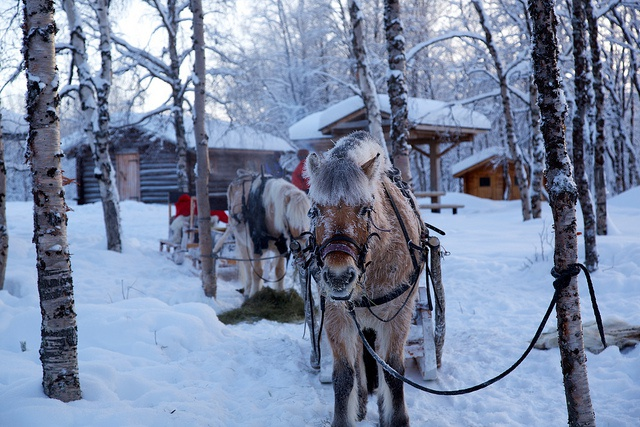Describe the objects in this image and their specific colors. I can see horse in lavender, gray, black, and darkgray tones, horse in lavender, gray, and black tones, people in lavender, purple, and black tones, and people in lavender, darkblue, navy, and blue tones in this image. 